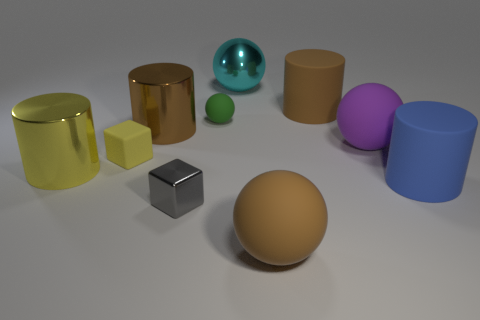Subtract 1 balls. How many balls are left? 3 Subtract all cylinders. How many objects are left? 6 Subtract 0 yellow balls. How many objects are left? 10 Subtract all tiny purple shiny cubes. Subtract all big metal spheres. How many objects are left? 9 Add 8 big blue rubber things. How many big blue rubber things are left? 9 Add 2 big green matte spheres. How many big green matte spheres exist? 2 